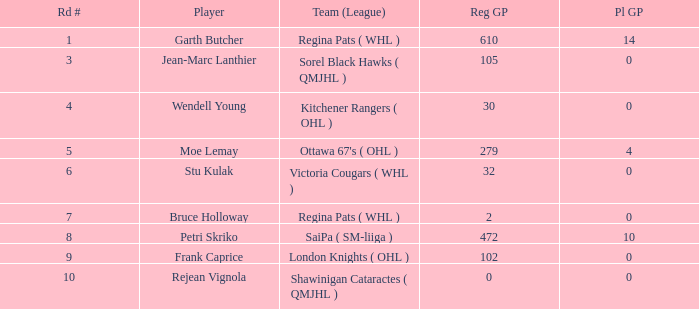What is the sum number of Pl GP when the pick number is 178 and the road number is bigger than 9? 0.0. 